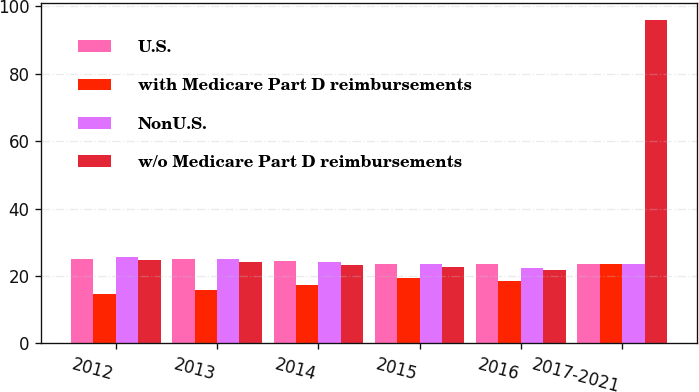Convert chart to OTSL. <chart><loc_0><loc_0><loc_500><loc_500><stacked_bar_chart><ecel><fcel>2012<fcel>2013<fcel>2014<fcel>2015<fcel>2016<fcel>2017-2021<nl><fcel>U.S.<fcel>25.1<fcel>25.1<fcel>24.6<fcel>23.7<fcel>23.6<fcel>23.6<nl><fcel>with Medicare Part D reimbursements<fcel>14.6<fcel>16<fcel>17.2<fcel>19.3<fcel>18.5<fcel>23.6<nl><fcel>NonU.S.<fcel>25.8<fcel>25<fcel>24.2<fcel>23.5<fcel>22.5<fcel>23.6<nl><fcel>w/o Medicare Part D reimbursements<fcel>24.9<fcel>24.1<fcel>23.4<fcel>22.6<fcel>21.7<fcel>96.1<nl></chart> 